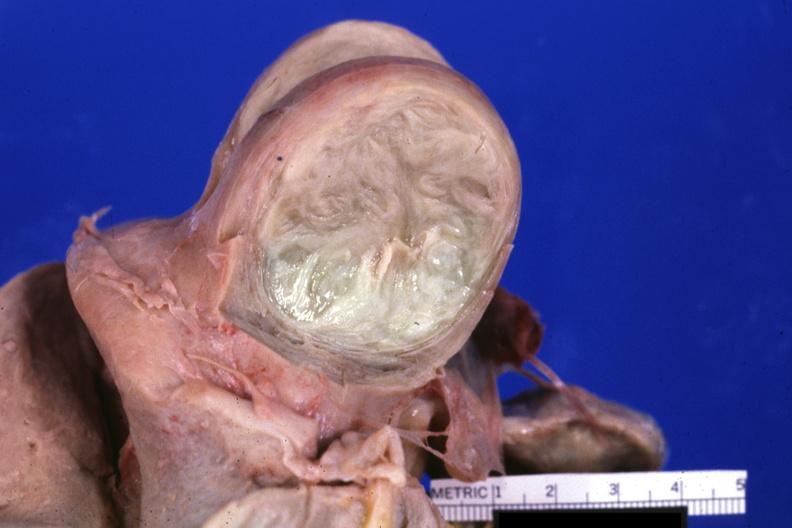s leg present?
Answer the question using a single word or phrase. No 